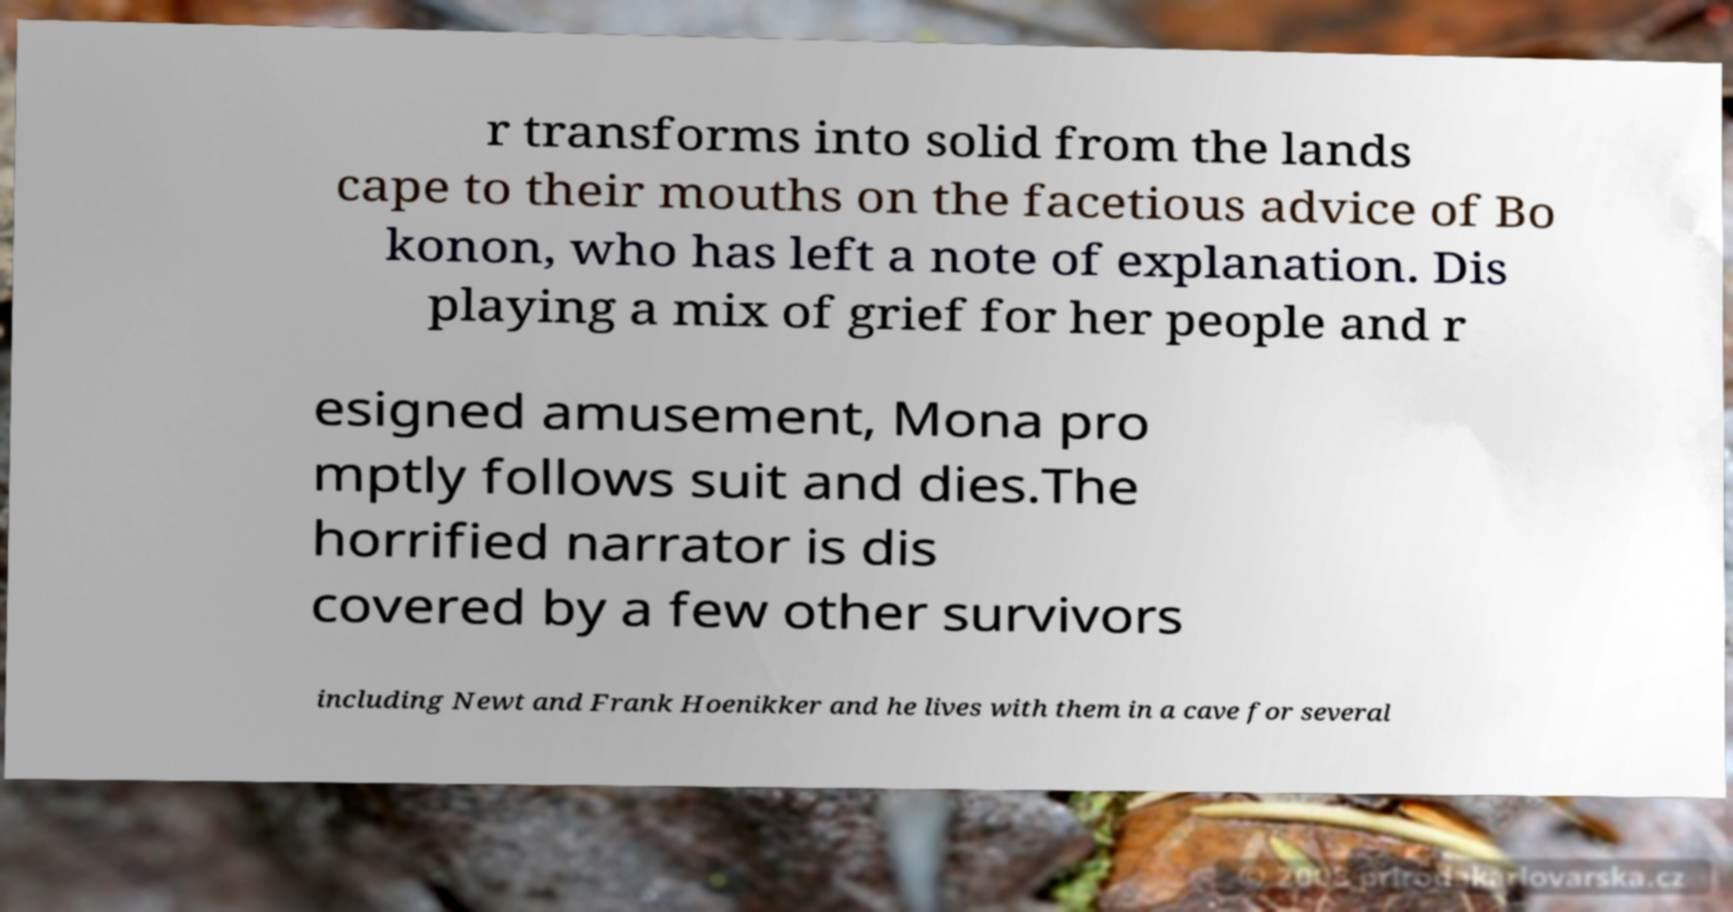For documentation purposes, I need the text within this image transcribed. Could you provide that? r transforms into solid from the lands cape to their mouths on the facetious advice of Bo konon, who has left a note of explanation. Dis playing a mix of grief for her people and r esigned amusement, Mona pro mptly follows suit and dies.The horrified narrator is dis covered by a few other survivors including Newt and Frank Hoenikker and he lives with them in a cave for several 